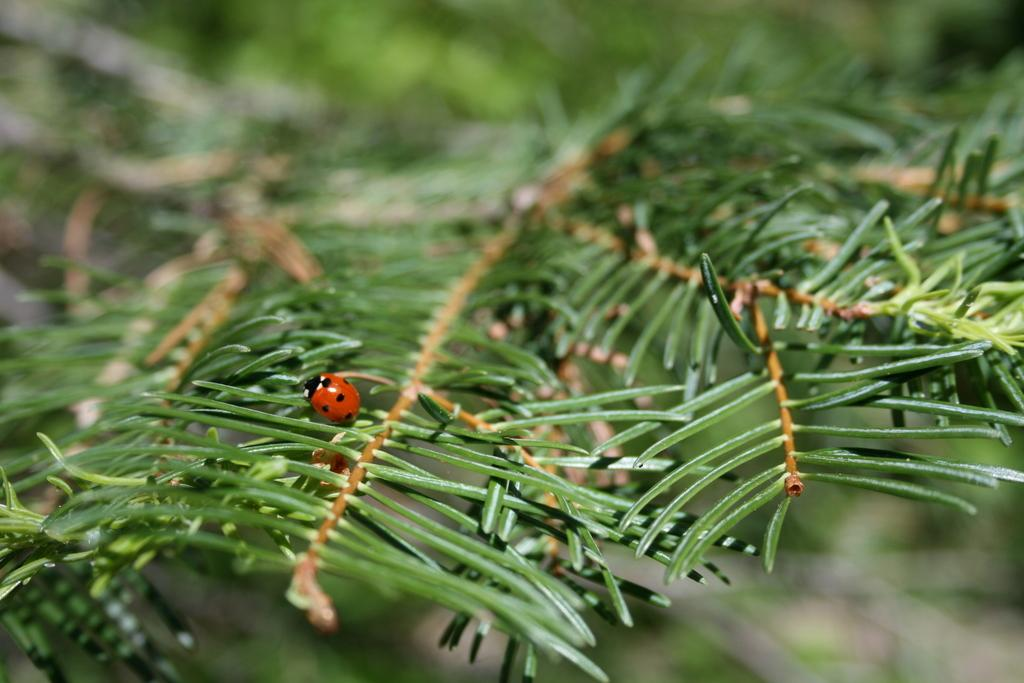What type of vegetation is present in the image? There are green trees in the image. Can you describe any living organisms on the trees? There is a red and black color insect on the tree. How would you characterize the background of the image? The background of the image is blurred. What type of chess piece can be seen on the tree in the image? There is no chess piece present in the image; it features green trees and a red and black color insect. How is the coal being used in the image? There is no coal present in the image. 